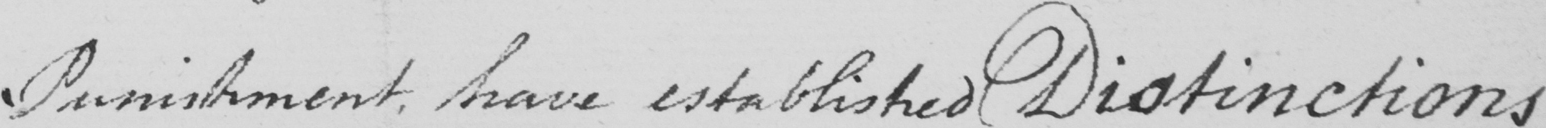What does this handwritten line say? Punishment , have established Distinctions 